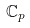<formula> <loc_0><loc_0><loc_500><loc_500>\mathbb { C } _ { p }</formula> 